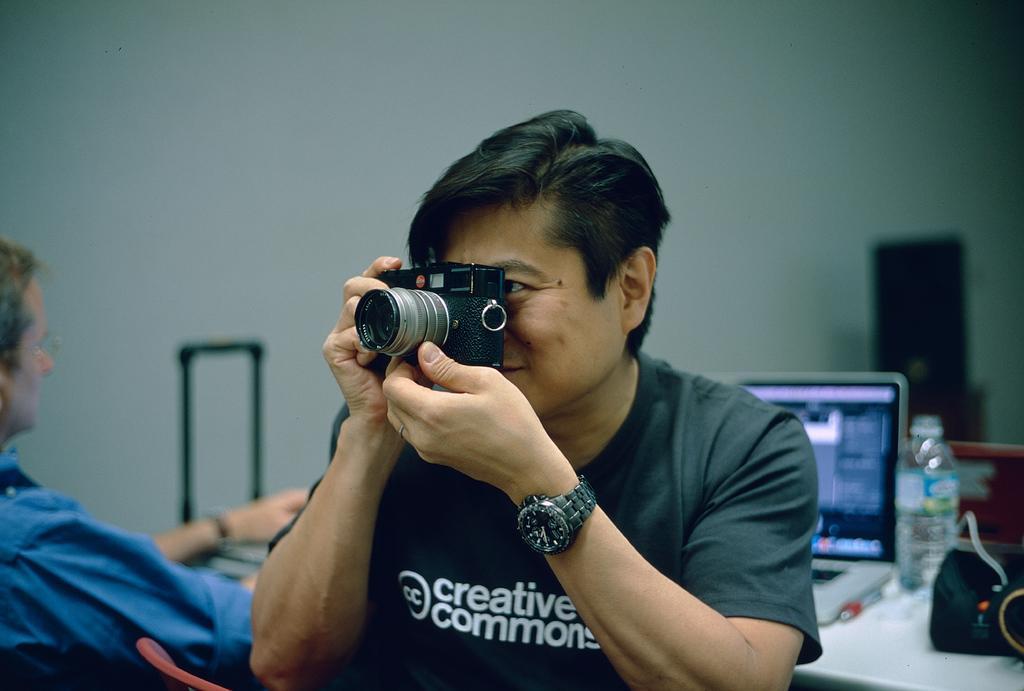Can you describe this image briefly? In this image we can see two people, among them one person is holding a camera and the other person is sitting in front of the table, on the table, we can see a laptop, bottle, pen and some other objects, in the background we can see the wall. 